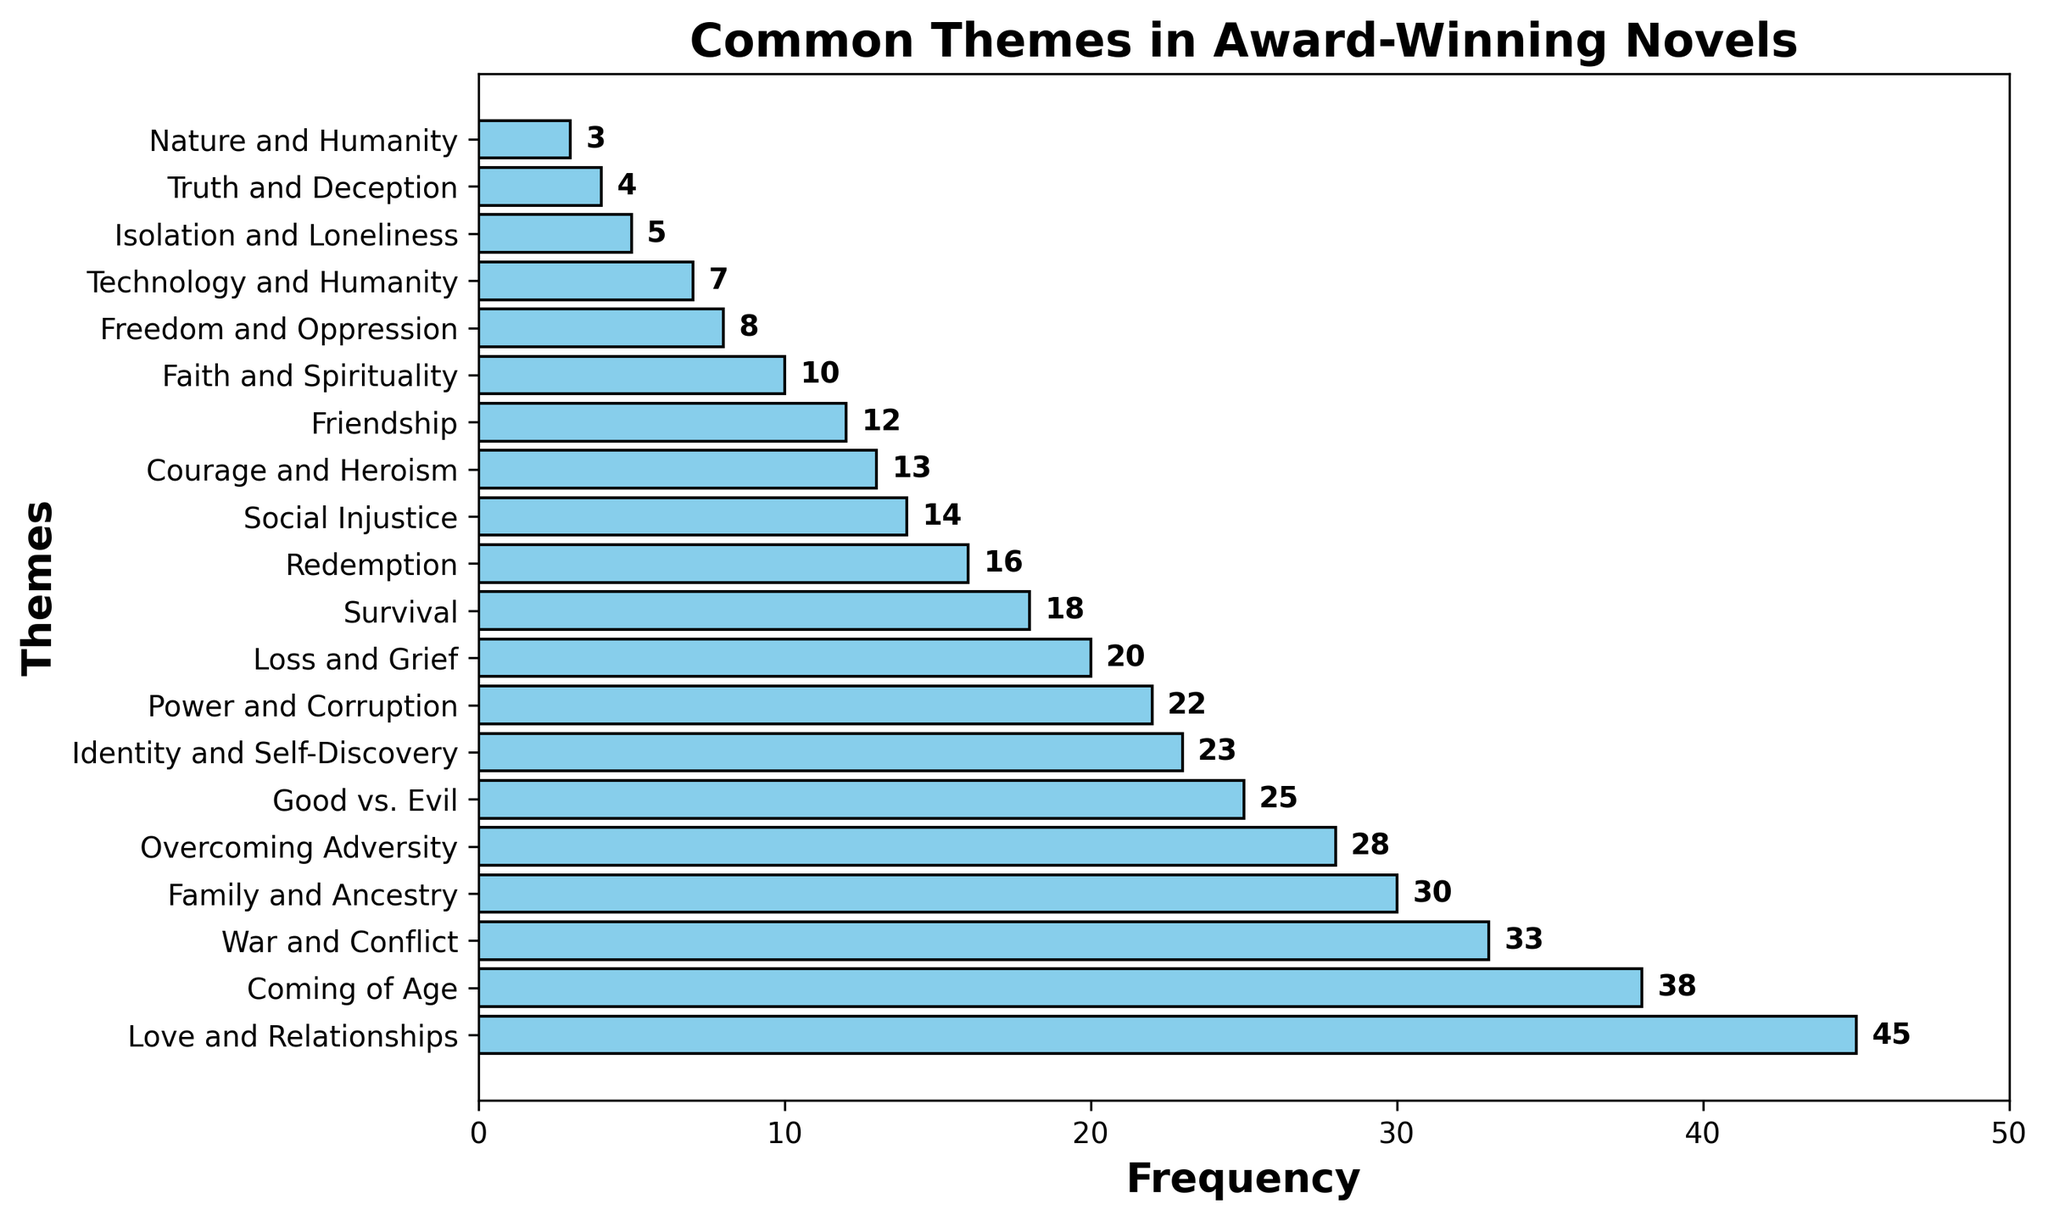What is the most common theme in award-winning novels? Locate the bar with the greatest length. Its label is "Love and Relationships" with a frequency of 45.
Answer: Love and Relationships Which theme has a frequency of 10? Find the bar corresponding to the frequency of 10 by checking the labels. The label for 10 is "Faith and Spirituality".
Answer: Faith and Spirituality How many themes have a frequency above 20? Count the number of bars with a length (frequency) greater than 20. These themes are: Love and Relationships (45), Coming of Age (38), War and Conflict (33), Family and Ancestry (30), Overcoming Adversity (28), Good vs. Evil (25), and Identity and Self-Discovery (23).
Answer: 7 Which themes have a lower frequency than "War and Conflict"? Identify the frequency of "War and Conflict" as 33. List the themes with frequencies less than 33 by examining the lengths of the bars below this threshold. These are: Family and Ancestry (30), Overcoming Adversity (28), Good vs. Evil (25), Identity and Self-Discovery (23), Power and Corruption (22), Loss and Grief (20), Survival (18), Redemption (16), Social Injustice (14), Courage and Heroism (13), Friendship (12), Faith and Spirituality (10), Freedom and Oppression (8), Technology and Humanity (7), Isolation and Loneliness (5), Truth and Deception (4), and Nature and Humanity (3).
Answer: Family and Ancestry, Overcoming Adversity, Good vs. Evil, Identity and Self-Discovery, Power and Corruption, Loss and Grief, Survival, Redemption, Social Injustice, Courage and Heroism, Friendship, Faith and Spirituality, Freedom and Oppression, Technology and Humanity, Isolation and Loneliness, Truth and Deception, Nature and Humanity What is the cumulative frequency of the themes "Love and Relationships" and "Coming of Age"? Sum the frequencies of these two themes: Love and Relationships (45) and Coming of Age (38): 45 + 38 = 83.
Answer: 83 Is the frequency of "Power and Corruption" greater than "Loss and Grief"? Compare the frequency values for both themes: Power and Corruption (22) and Loss and Grief (20). Since 22 > 20, "Power and Corruption" has a higher frequency.
Answer: Yes What percentage of the total frequency does "Survival" represent? First, calculate the total frequency by summing all the frequencies: 45 + 38 + 33 + 30 + 28 + 25 + 23 + 22 + 20 + 18 + 16 + 14 + 13 + 12 + 10 + 8 + 7 + 5 + 4 + 3 = 374. Next, find the frequency of "Survival" (18). Then, divide Survival’s frequency by the total and multiply by 100 to get the percentage: (18 / 374) * 100 ≈ 4.81%.
Answer: 4.81% By how much does "War and Conflict" exceed "Good vs. Evil"? Subtract the frequency of "Good vs. Evil" (25) from "War and Conflict" (33). The difference is 33 - 25 = 8.
Answer: 8 Which theme has the second lowest frequency? Rank the themes by frequency in ascending order and identify the second lowest. The two lowest frequencies are 3 ("Nature and Humanity") and 4 ("Truth and Deception"). Therefore, the second lowest is "Truth and Deception".
Answer: Truth and Deception 